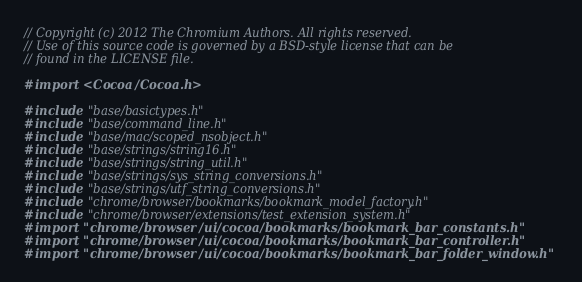Convert code to text. <code><loc_0><loc_0><loc_500><loc_500><_ObjectiveC_>// Copyright (c) 2012 The Chromium Authors. All rights reserved.
// Use of this source code is governed by a BSD-style license that can be
// found in the LICENSE file.

#import <Cocoa/Cocoa.h>

#include "base/basictypes.h"
#include "base/command_line.h"
#include "base/mac/scoped_nsobject.h"
#include "base/strings/string16.h"
#include "base/strings/string_util.h"
#include "base/strings/sys_string_conversions.h"
#include "base/strings/utf_string_conversions.h"
#include "chrome/browser/bookmarks/bookmark_model_factory.h"
#include "chrome/browser/extensions/test_extension_system.h"
#import "chrome/browser/ui/cocoa/bookmarks/bookmark_bar_constants.h"
#import "chrome/browser/ui/cocoa/bookmarks/bookmark_bar_controller.h"
#import "chrome/browser/ui/cocoa/bookmarks/bookmark_bar_folder_window.h"</code> 